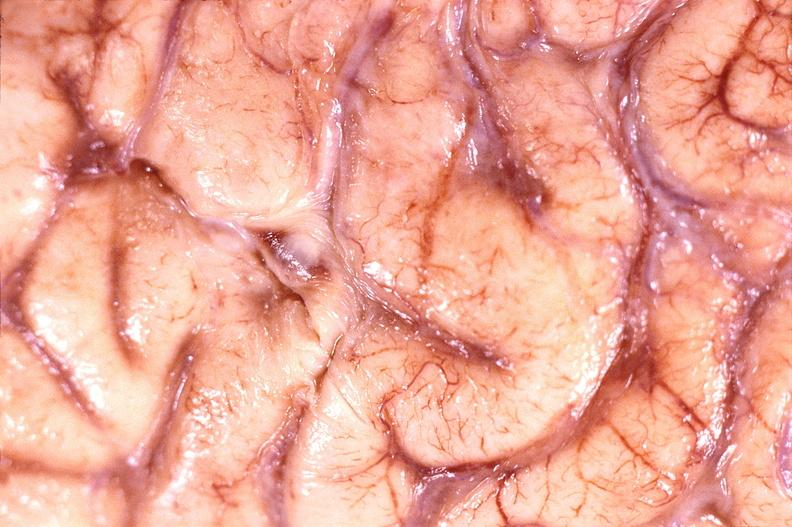what does this image show?
Answer the question using a single word or phrase. Brain abscess 